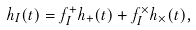Convert formula to latex. <formula><loc_0><loc_0><loc_500><loc_500>h _ { I } ( t ) = f ^ { + } _ { I } h _ { + } ( t ) + f ^ { \times } _ { I } h _ { \times } ( t ) ,</formula> 